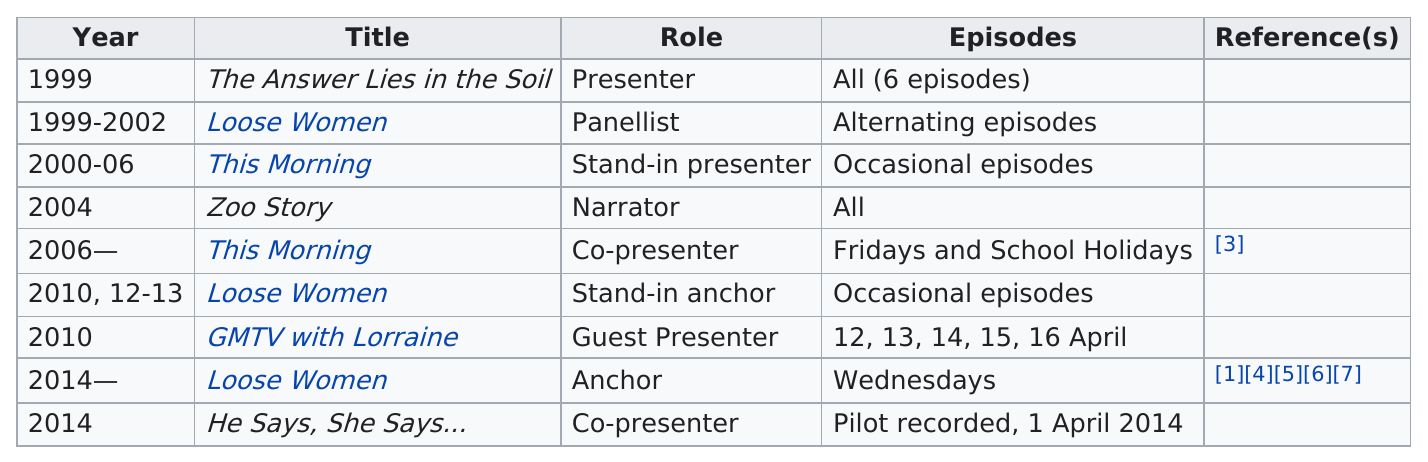Outline some significant characteristics in this image. Immediately after 'This Morning', the next title was 'Zoo Story'. The last role listed on this chart is 'Co-presenter.' The zoo story ran longer than Loose Women, and Loose Women was the one that ran longer. The title listed after "Zoo Story" is "This Morning. The title of the first book is the answer to the problem in the soil. 